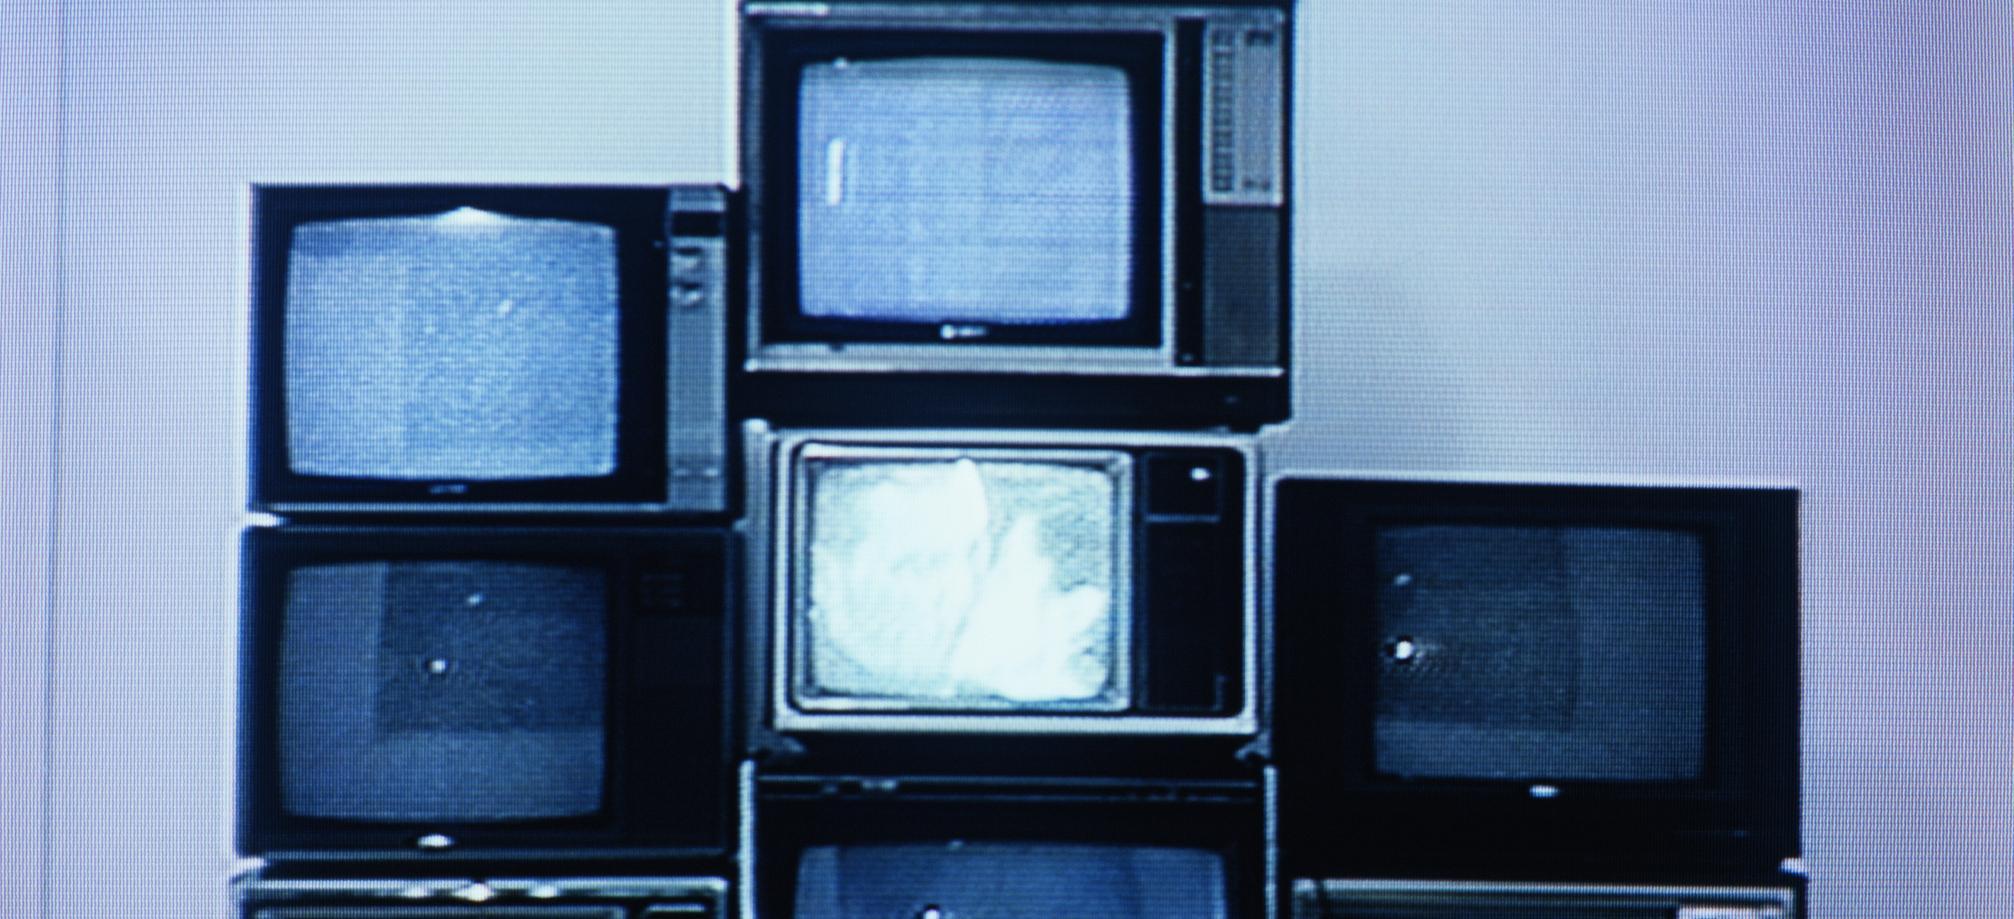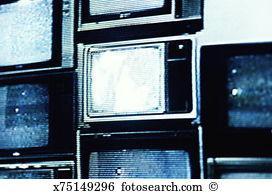The first image is the image on the left, the second image is the image on the right. Given the left and right images, does the statement "the right image contains 1 tv" hold true? Answer yes or no. No. The first image is the image on the left, the second image is the image on the right. For the images displayed, is the sentence "There is exactly one television in the right image and multiple televisions in the left image." factually correct? Answer yes or no. No. 